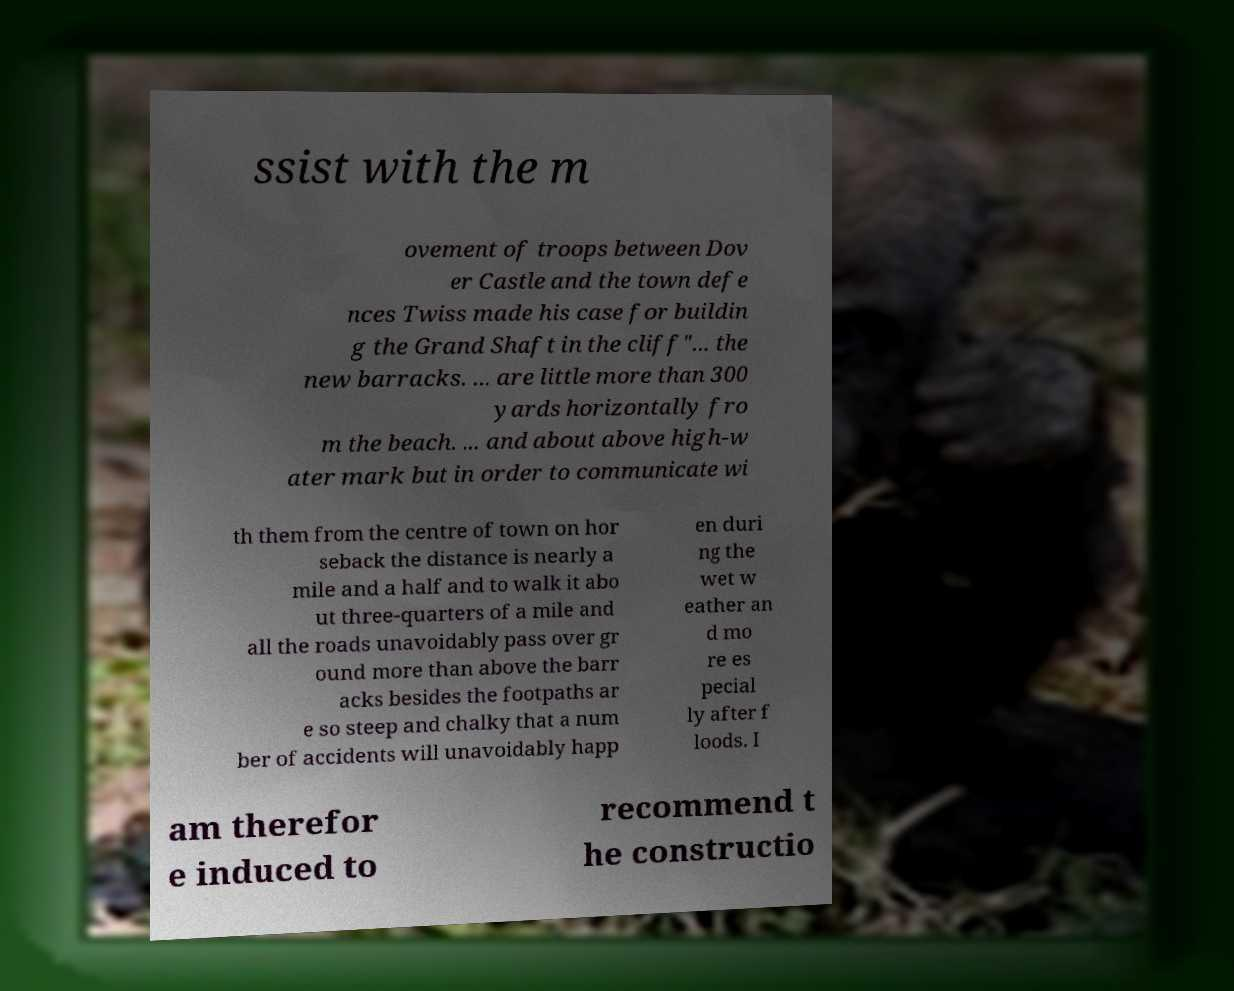I need the written content from this picture converted into text. Can you do that? ssist with the m ovement of troops between Dov er Castle and the town defe nces Twiss made his case for buildin g the Grand Shaft in the cliff"... the new barracks. ... are little more than 300 yards horizontally fro m the beach. ... and about above high-w ater mark but in order to communicate wi th them from the centre of town on hor seback the distance is nearly a mile and a half and to walk it abo ut three-quarters of a mile and all the roads unavoidably pass over gr ound more than above the barr acks besides the footpaths ar e so steep and chalky that a num ber of accidents will unavoidably happ en duri ng the wet w eather an d mo re es pecial ly after f loods. I am therefor e induced to recommend t he constructio 